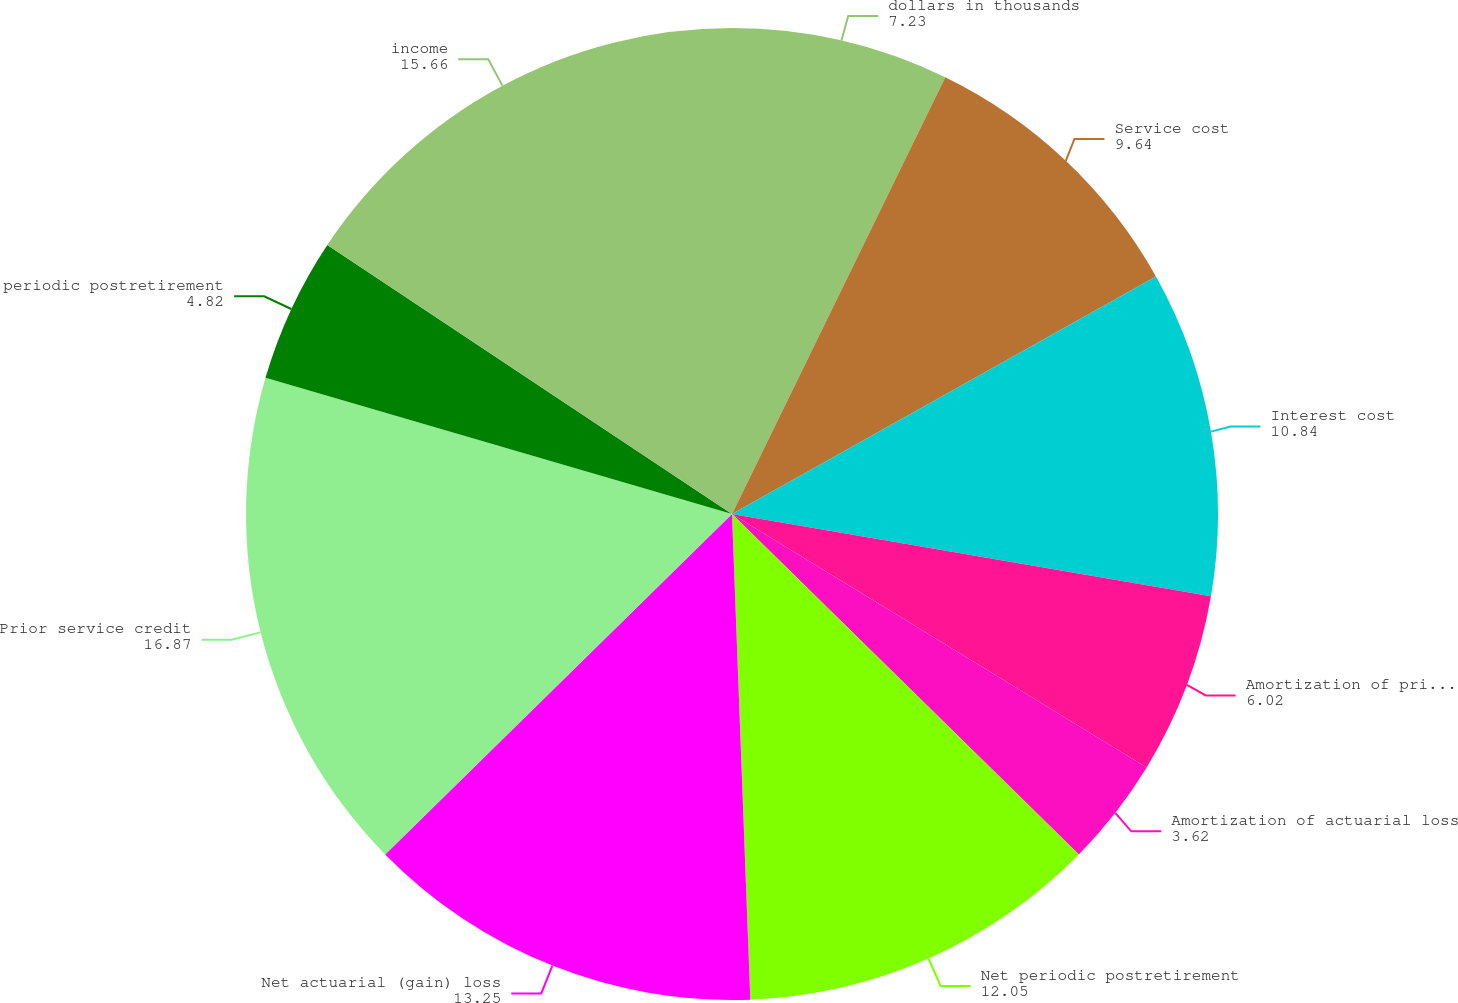<chart> <loc_0><loc_0><loc_500><loc_500><pie_chart><fcel>dollars in thousands<fcel>Service cost<fcel>Interest cost<fcel>Amortization of prior service<fcel>Amortization of actuarial loss<fcel>Net periodic postretirement<fcel>Net actuarial (gain) loss<fcel>Prior service credit<fcel>periodic postretirement<fcel>income<nl><fcel>7.23%<fcel>9.64%<fcel>10.84%<fcel>6.02%<fcel>3.62%<fcel>12.05%<fcel>13.25%<fcel>16.87%<fcel>4.82%<fcel>15.66%<nl></chart> 